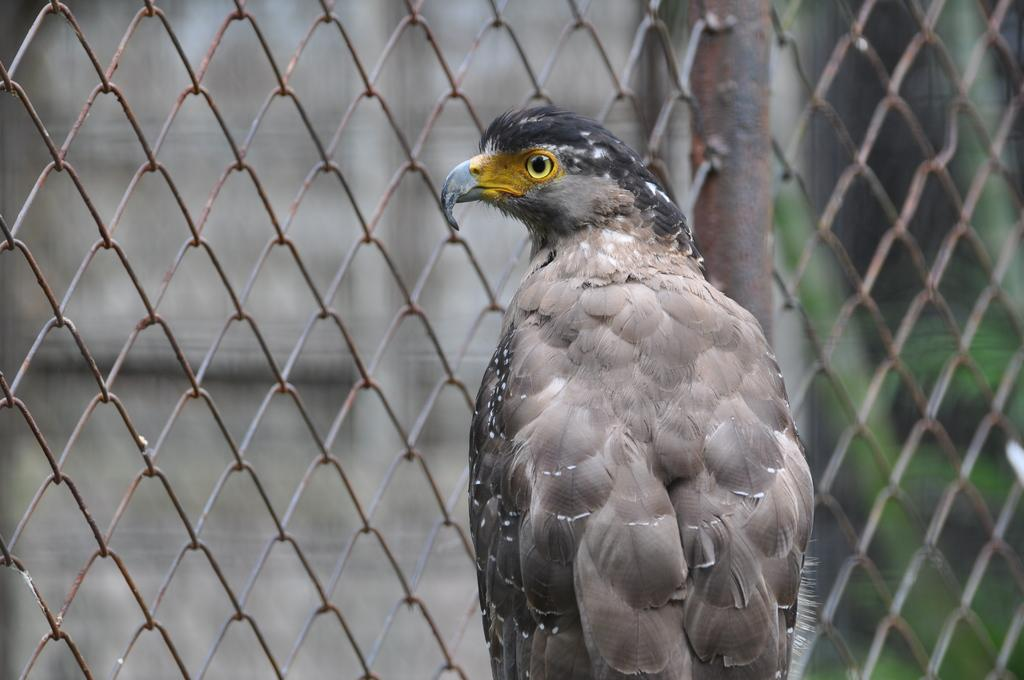What type of animal can be seen in the image? There is a bird in the image. Where is the bird located in relation to the fencing? The bird is in front of the fencing. What type of comfort does the bird provide to the person in the image? There is no person present in the image, and the bird's comfort cannot be determined. 